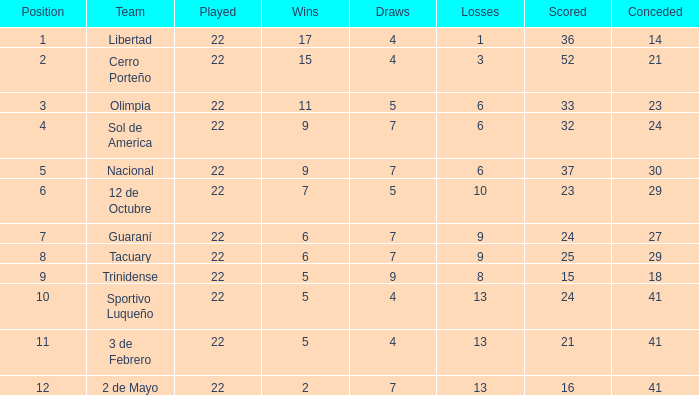What is the quantity of stalemates for the group with in excess of 8 losses and 13 points? 7.0. 